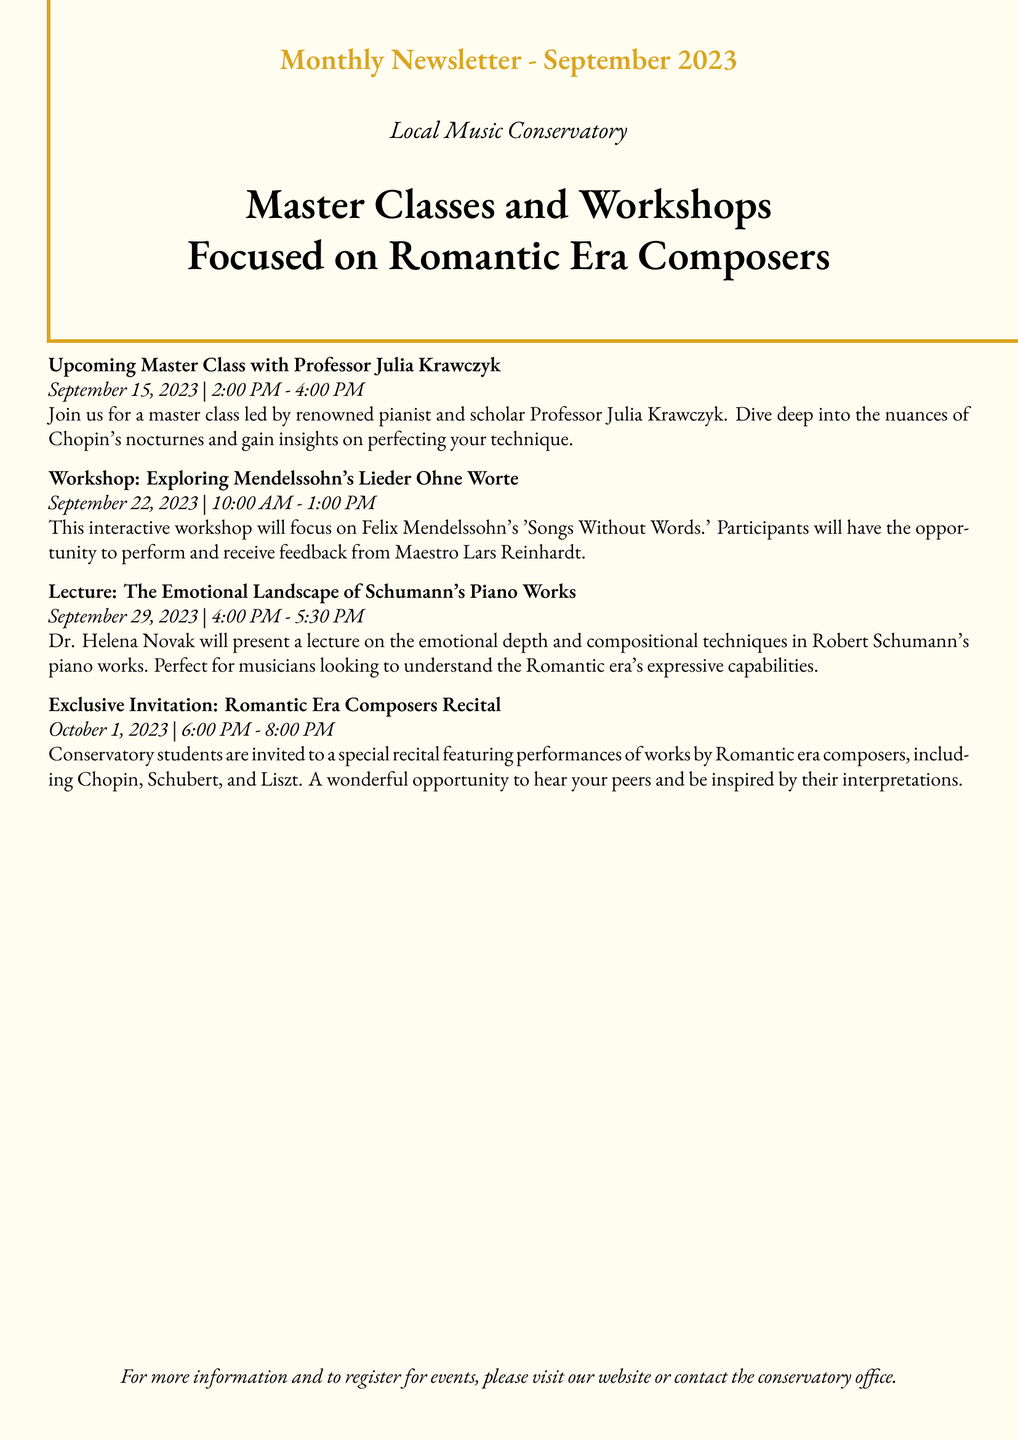What is the date of the master class with Professor Julia Krawczyk? The master class is scheduled for September 15, 2023.
Answer: September 15, 2023 Who will lead the workshop on Mendelssohn's 'Songs Without Words'? The workshop will be led by Maestro Lars Reinhardt.
Answer: Maestro Lars Reinhardt What time does the lecture on Schumann's piano works start? The lecture starts at 4:00 PM.
Answer: 4:00 PM What is the focus of the exclusive recital on October 1, 2023? The recital features performances of works by Romantic era composers.
Answer: Romantic era composers How long is the master class with Professor Julia Krawczyk? The master class lasts for 2 hours, from 2:00 PM to 4:00 PM.
Answer: 2 hours Which composer’s works are featured in the emotional landscape lecture? The lecture focuses on Robert Schumann's piano works.
Answer: Robert Schumann's When is the workshop scheduled? The workshop is set for September 22, 2023.
Answer: September 22, 2023 How many events are listed in the newsletter? There are four events mentioned in the newsletter.
Answer: Four events What opportunity does the recital provide to conservatory students? The recital is a chance to hear their peers and be inspired by their interpretations.
Answer: Hear peers' interpretations 